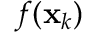<formula> <loc_0><loc_0><loc_500><loc_500>f ( x _ { k } )</formula> 